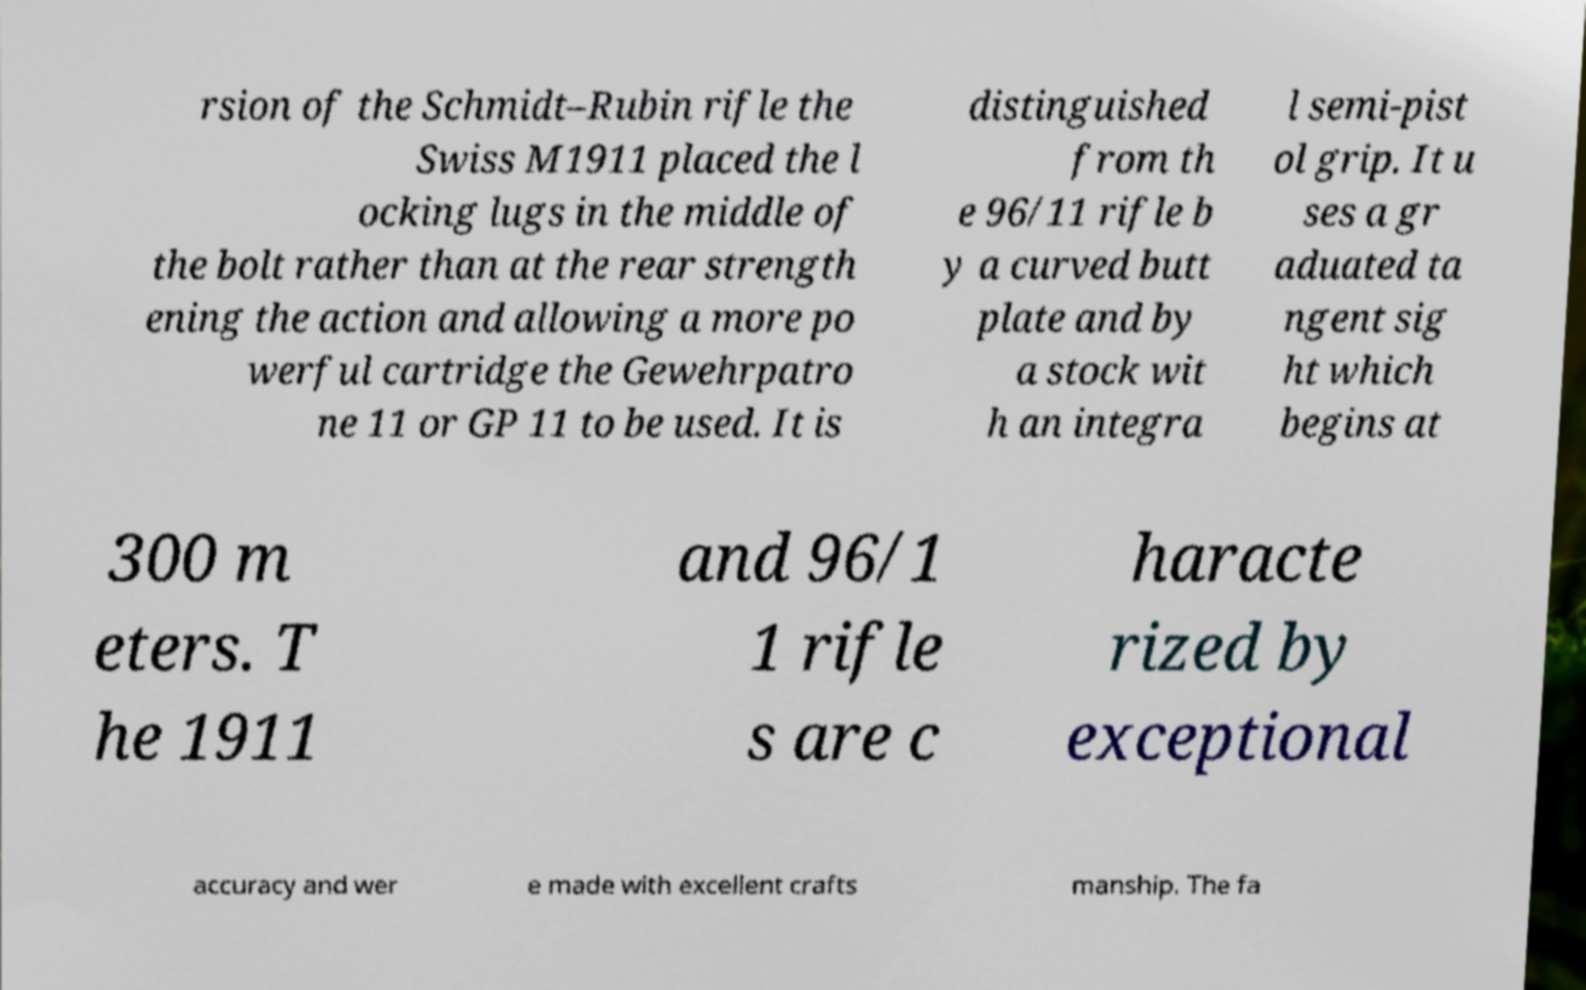Can you accurately transcribe the text from the provided image for me? rsion of the Schmidt–Rubin rifle the Swiss M1911 placed the l ocking lugs in the middle of the bolt rather than at the rear strength ening the action and allowing a more po werful cartridge the Gewehrpatro ne 11 or GP 11 to be used. It is distinguished from th e 96/11 rifle b y a curved butt plate and by a stock wit h an integra l semi-pist ol grip. It u ses a gr aduated ta ngent sig ht which begins at 300 m eters. T he 1911 and 96/1 1 rifle s are c haracte rized by exceptional accuracy and wer e made with excellent crafts manship. The fa 